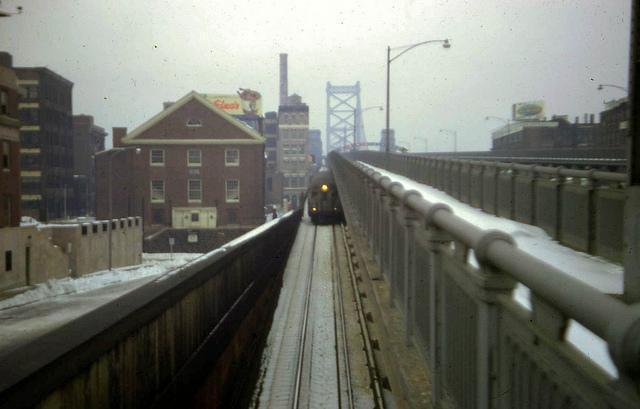How many wine bottles sit on the counter?
Give a very brief answer. 0. 